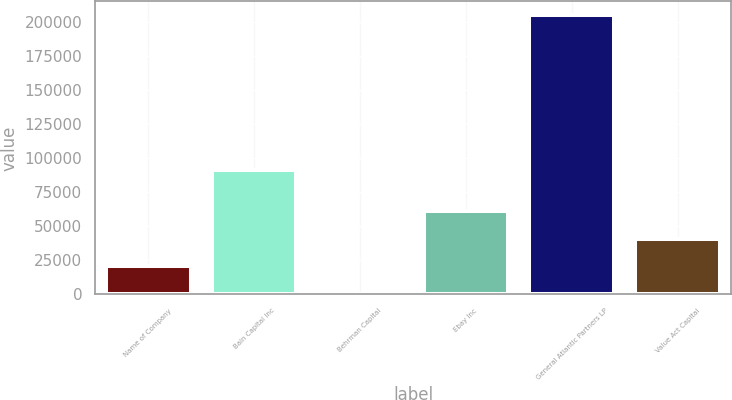Convert chart to OTSL. <chart><loc_0><loc_0><loc_500><loc_500><bar_chart><fcel>Name of Company<fcel>Bain Capital Inc<fcel>Behrman Capital<fcel>Ebay Inc<fcel>General Atlantic Partners LP<fcel>Value Act Capital<nl><fcel>20501.7<fcel>91550<fcel>1.84<fcel>61501.3<fcel>205000<fcel>41001.5<nl></chart> 